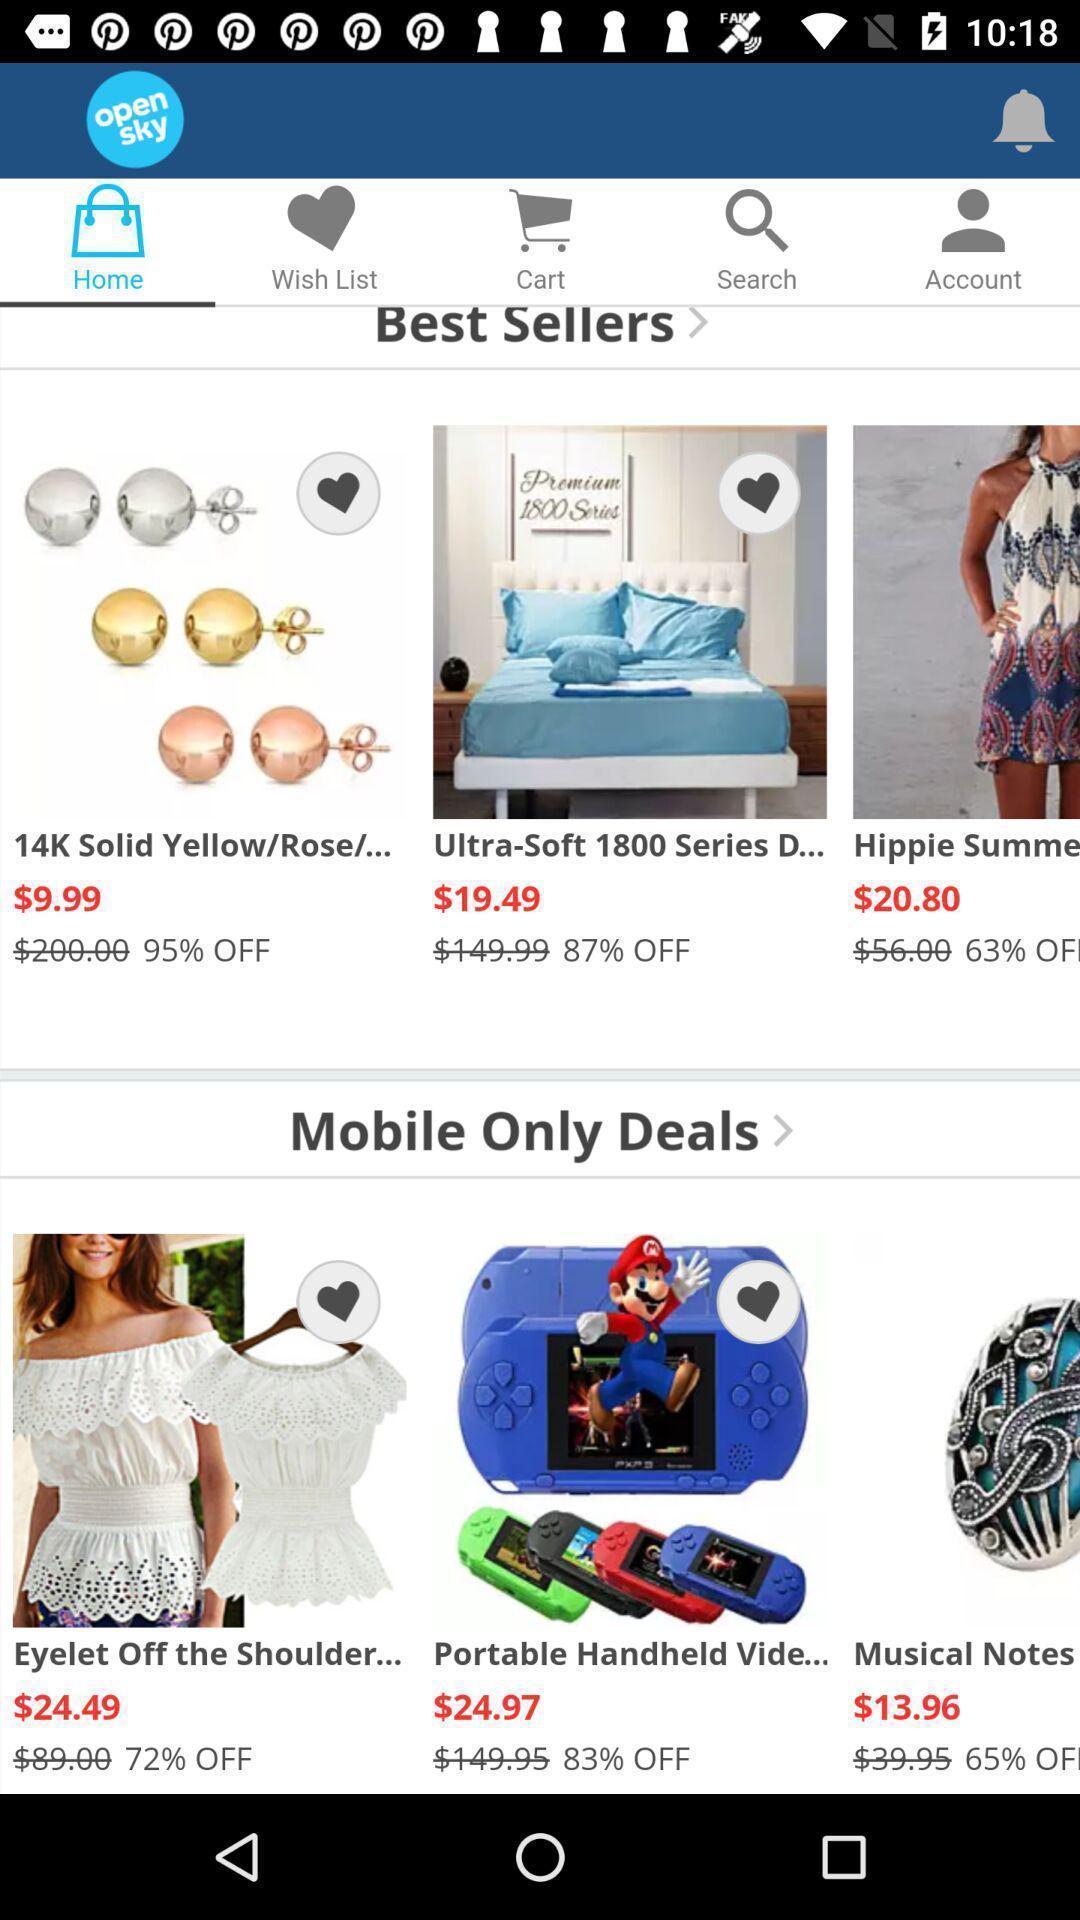Give me a narrative description of this picture. Home page in a shopping app. 